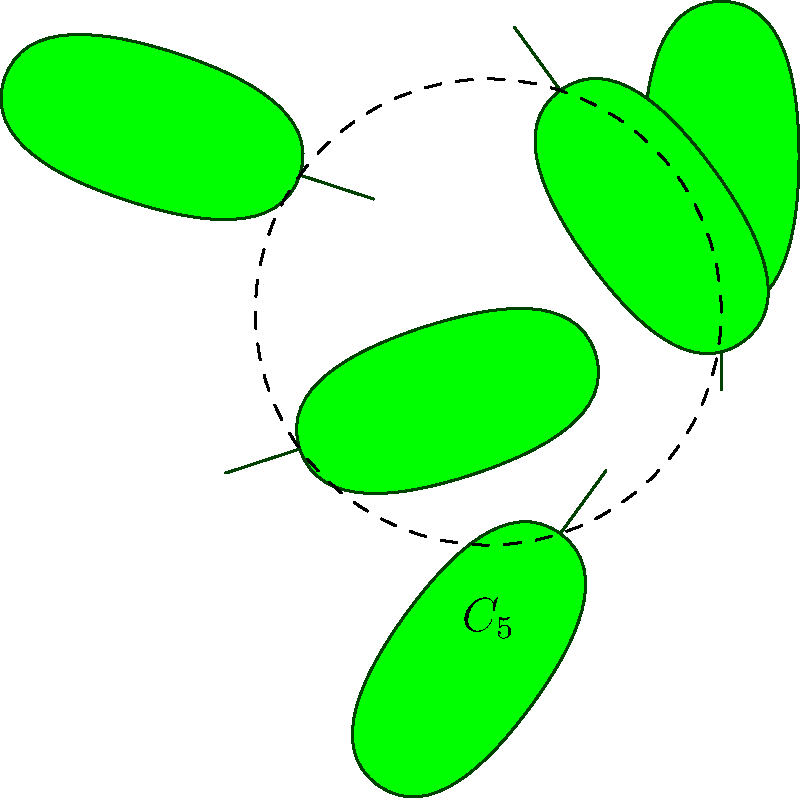In the arrangement of cannabis leaves shown above, what is the order of rotational symmetry, and what group does this symmetry correspond to? To determine the order of rotational symmetry and the corresponding group, we need to follow these steps:

1. Observe the arrangement: The cannabis leaves are arranged in a circular pattern around a central point.

2. Count the number of leaves: There are 5 leaves in the arrangement.

3. Determine the angle between leaves: The angle between each leaf is $\frac{360°}{5} = 72°$.

4. Identify rotational symmetry: The arrangement looks the same when rotated by 72°, 144°, 216°, 288°, and 360° (back to the starting position).

5. Determine the order of rotational symmetry: The number of distinct rotations that preserve the arrangement is 5.

6. Identify the corresponding group: This symmetry corresponds to the cyclic group of order 5, denoted as $C_5$ or $\mathbb{Z}_5$.

7. Group properties: $C_5$ is an abelian group with 5 elements, generated by a single rotation of 72°. Its elements are $\{e, r, r^2, r^3, r^4\}$, where $e$ is the identity and $r$ is a 72° rotation.
Answer: Order 5; Cyclic group $C_5$ 